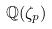<formula> <loc_0><loc_0><loc_500><loc_500>\mathbb { Q } ( \zeta _ { p } )</formula> 